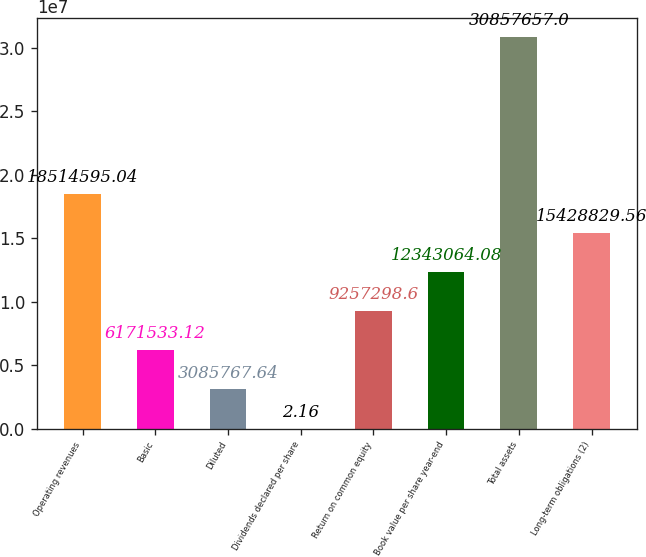Convert chart. <chart><loc_0><loc_0><loc_500><loc_500><bar_chart><fcel>Operating revenues<fcel>Basic<fcel>Diluted<fcel>Dividends declared per share<fcel>Return on common equity<fcel>Book value per share year-end<fcel>Total assets<fcel>Long-term obligations (2)<nl><fcel>1.85146e+07<fcel>6.17153e+06<fcel>3.08577e+06<fcel>2.16<fcel>9.2573e+06<fcel>1.23431e+07<fcel>3.08577e+07<fcel>1.54288e+07<nl></chart> 